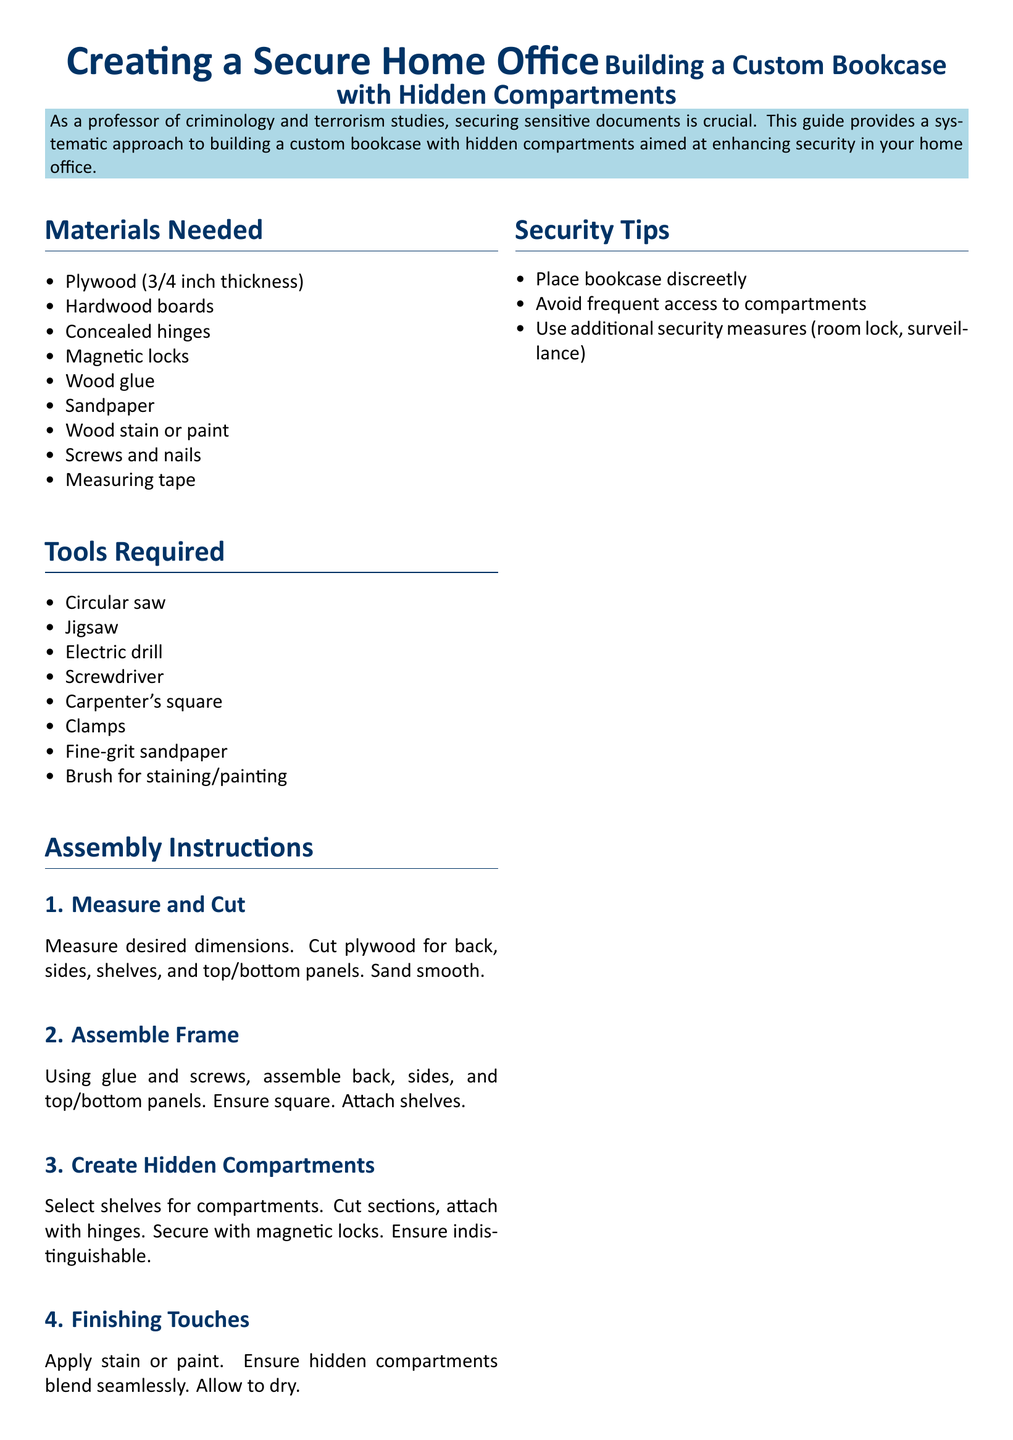what is the thickness of the plywood required? The document states that 3/4 inch thickness plywood is needed for the construction.
Answer: 3/4 inch how many tools are listed in the document? The document provides a total of 8 tools required for the assembly instructions.
Answer: 8 which section describes the finishing process? The finishing process is described under the subsection titled "Finishing Touches."
Answer: Finishing Touches what is used to secure hidden compartments? The hidden compartments are secured with magnetic locks as stated in the assembly instructions.
Answer: Magnetic locks what should be used for blending the hidden compartments? The document recommends using stain or paint to ensure the hidden compartments blend seamlessly.
Answer: Stain or paint how many materials are listed as needed? The document lists a total of 8 materials required for building the custom bookcase.
Answer: 8 what is the first step in the assembly instructions? The first step listed in the assembly instructions is to measure and cut the plywood.
Answer: Measure and Cut what is a security tip provided for the bookcase? One of the security tips suggests placing the bookcase discreetly to enhance security.
Answer: Place bookcase discreetly what does the diagram illustrate? The diagram illustrates the top view of a shelf with a hidden compartment, highlighting its design.
Answer: Top View of Shelf with Hidden Compartment 